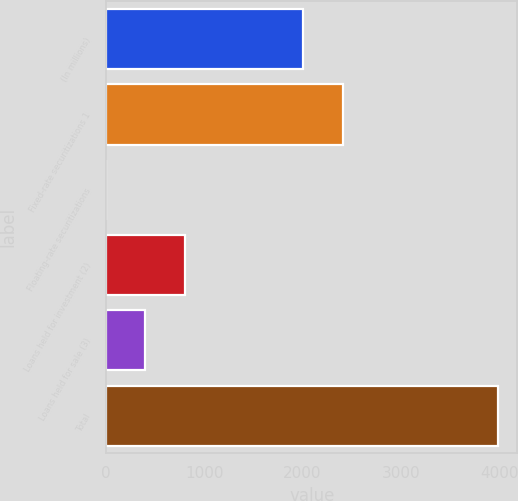Convert chart. <chart><loc_0><loc_0><loc_500><loc_500><bar_chart><fcel>(In millions)<fcel>Fixed-rate securitizations 1<fcel>Floating-rate securitizations<fcel>Loans held for investment (2)<fcel>Loans held for sale (3)<fcel>Total<nl><fcel>2009<fcel>2407.61<fcel>0.6<fcel>797.82<fcel>399.21<fcel>3986.7<nl></chart> 